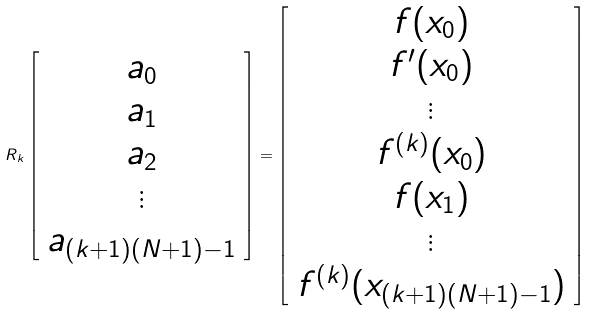Convert formula to latex. <formula><loc_0><loc_0><loc_500><loc_500>R _ { k } \left [ \begin{array} { c c c c c c c } a _ { 0 } \\ a _ { 1 } \\ a _ { 2 } \\ \vdots \\ a _ { ( k + 1 ) ( N + 1 ) - 1 } \end{array} \right ] = \left [ \begin{array} { c c c c c c c } f ( x _ { 0 } ) \\ f ^ { \prime } ( x _ { 0 } ) \\ \vdots \\ f ^ { ( k ) } ( x _ { 0 } ) \\ f ( x _ { 1 } ) \\ \vdots \\ f ^ { ( k ) } ( x _ { ( k + 1 ) ( N + 1 ) - 1 } ) \end{array} \right ]</formula> 